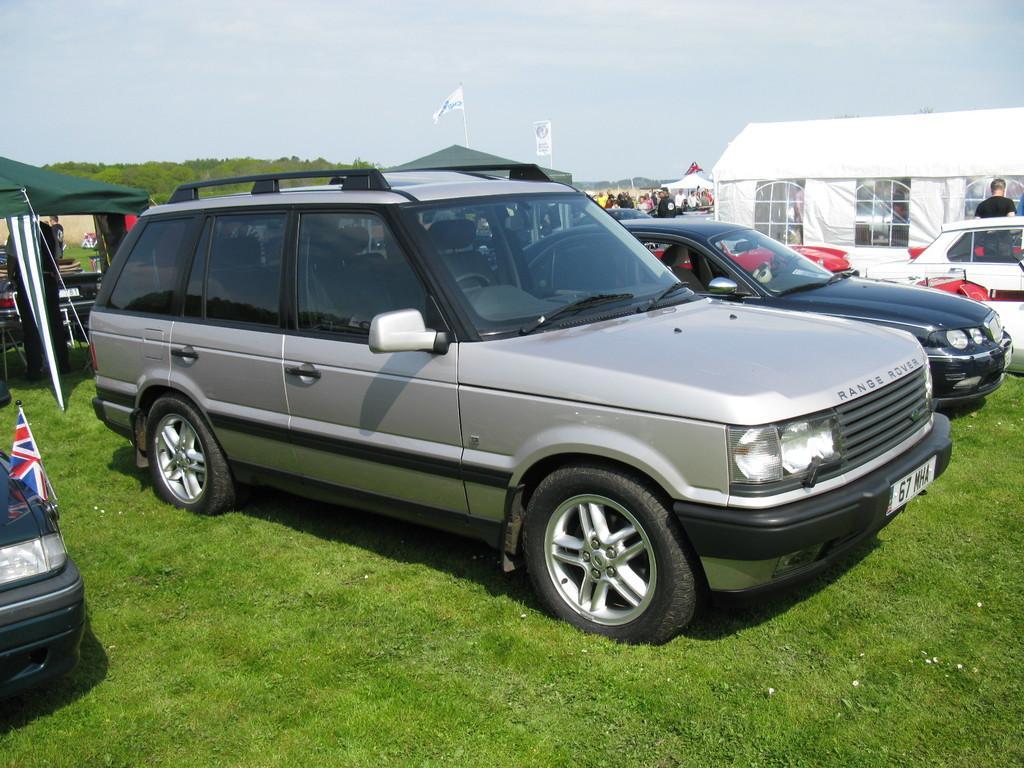How would you summarize this image in a sentence or two? In the image I can see some cars on the ground also I can see some trees, poles and a tent like thing to the side. 